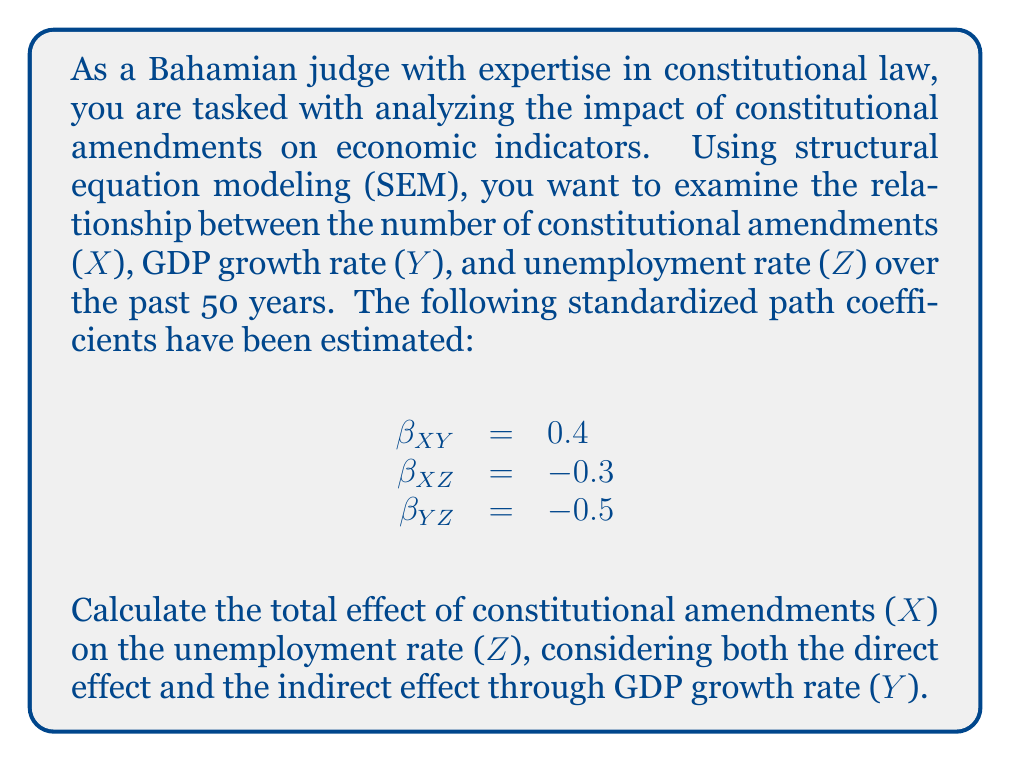Can you solve this math problem? To solve this problem using structural equation modeling, we need to consider both the direct and indirect effects of constitutional amendments (X) on the unemployment rate (Z).

1. Direct effect:
The direct effect of X on Z is given by the path coefficient $\beta_{XZ} = -0.3$.

2. Indirect effect:
The indirect effect of X on Z through Y is calculated by multiplying the path coefficients:
$\beta_{XY} \times \beta_{YZ} = 0.4 \times (-0.5) = -0.2$

3. Total effect:
The total effect is the sum of the direct and indirect effects:

$$\text{Total Effect} = \text{Direct Effect} + \text{Indirect Effect}$$
$$\text{Total Effect} = \beta_{XZ} + (\beta_{XY} \times \beta_{YZ})$$
$$\text{Total Effect} = -0.3 + (-0.2) = -0.5$$

This means that for every one standard deviation increase in the number of constitutional amendments, we expect a 0.5 standard deviation decrease in the unemployment rate, considering both the direct effect and the indirect effect through GDP growth rate.
Answer: The total effect of constitutional amendments (X) on the unemployment rate (Z) is $-0.5$. 